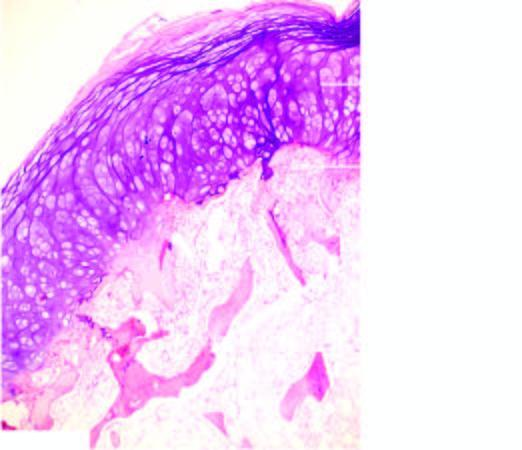what shows mature cartilage cells covering the underlying mature lamellar bone containing marrow spaces?
Answer the question using a single word or phrase. Overlying cap 